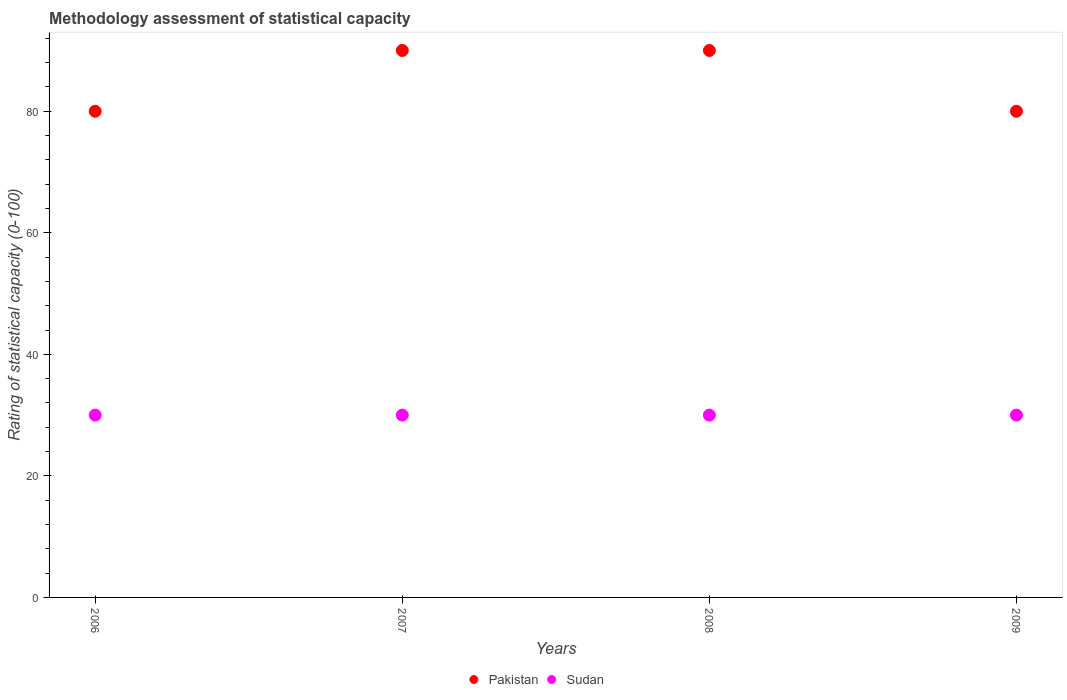How many different coloured dotlines are there?
Your answer should be compact. 2. Is the number of dotlines equal to the number of legend labels?
Keep it short and to the point. Yes. What is the rating of statistical capacity in Pakistan in 2009?
Your response must be concise. 80. Across all years, what is the maximum rating of statistical capacity in Sudan?
Provide a short and direct response. 30. Across all years, what is the minimum rating of statistical capacity in Pakistan?
Keep it short and to the point. 80. What is the total rating of statistical capacity in Pakistan in the graph?
Provide a short and direct response. 340. What is the difference between the rating of statistical capacity in Pakistan in 2007 and that in 2009?
Make the answer very short. 10. What is the difference between the rating of statistical capacity in Sudan in 2008 and the rating of statistical capacity in Pakistan in 2009?
Offer a very short reply. -50. In the year 2008, what is the difference between the rating of statistical capacity in Pakistan and rating of statistical capacity in Sudan?
Give a very brief answer. 60. In how many years, is the rating of statistical capacity in Sudan greater than 88?
Your answer should be very brief. 0. Is the rating of statistical capacity in Pakistan in 2006 less than that in 2008?
Provide a short and direct response. Yes. Is the difference between the rating of statistical capacity in Pakistan in 2008 and 2009 greater than the difference between the rating of statistical capacity in Sudan in 2008 and 2009?
Offer a very short reply. Yes. What is the difference between the highest and the lowest rating of statistical capacity in Sudan?
Ensure brevity in your answer.  0. In how many years, is the rating of statistical capacity in Sudan greater than the average rating of statistical capacity in Sudan taken over all years?
Your answer should be very brief. 0. How many dotlines are there?
Your answer should be very brief. 2. What is the difference between two consecutive major ticks on the Y-axis?
Your answer should be compact. 20. Where does the legend appear in the graph?
Your answer should be compact. Bottom center. How many legend labels are there?
Provide a succinct answer. 2. What is the title of the graph?
Offer a terse response. Methodology assessment of statistical capacity. Does "Haiti" appear as one of the legend labels in the graph?
Give a very brief answer. No. What is the label or title of the X-axis?
Ensure brevity in your answer.  Years. What is the label or title of the Y-axis?
Your response must be concise. Rating of statistical capacity (0-100). What is the Rating of statistical capacity (0-100) of Sudan in 2007?
Give a very brief answer. 30. What is the Rating of statistical capacity (0-100) in Pakistan in 2008?
Offer a terse response. 90. Across all years, what is the maximum Rating of statistical capacity (0-100) of Pakistan?
Your answer should be very brief. 90. Across all years, what is the maximum Rating of statistical capacity (0-100) in Sudan?
Give a very brief answer. 30. Across all years, what is the minimum Rating of statistical capacity (0-100) in Pakistan?
Make the answer very short. 80. Across all years, what is the minimum Rating of statistical capacity (0-100) of Sudan?
Offer a very short reply. 30. What is the total Rating of statistical capacity (0-100) of Pakistan in the graph?
Ensure brevity in your answer.  340. What is the total Rating of statistical capacity (0-100) in Sudan in the graph?
Keep it short and to the point. 120. What is the difference between the Rating of statistical capacity (0-100) in Sudan in 2006 and that in 2008?
Ensure brevity in your answer.  0. What is the difference between the Rating of statistical capacity (0-100) in Sudan in 2007 and that in 2008?
Ensure brevity in your answer.  0. What is the difference between the Rating of statistical capacity (0-100) of Pakistan in 2008 and that in 2009?
Ensure brevity in your answer.  10. What is the difference between the Rating of statistical capacity (0-100) of Pakistan in 2006 and the Rating of statistical capacity (0-100) of Sudan in 2008?
Your response must be concise. 50. What is the difference between the Rating of statistical capacity (0-100) of Pakistan in 2006 and the Rating of statistical capacity (0-100) of Sudan in 2009?
Your answer should be very brief. 50. What is the difference between the Rating of statistical capacity (0-100) of Pakistan in 2008 and the Rating of statistical capacity (0-100) of Sudan in 2009?
Make the answer very short. 60. What is the average Rating of statistical capacity (0-100) of Pakistan per year?
Your response must be concise. 85. What is the average Rating of statistical capacity (0-100) in Sudan per year?
Your response must be concise. 30. In the year 2006, what is the difference between the Rating of statistical capacity (0-100) of Pakistan and Rating of statistical capacity (0-100) of Sudan?
Give a very brief answer. 50. In the year 2007, what is the difference between the Rating of statistical capacity (0-100) of Pakistan and Rating of statistical capacity (0-100) of Sudan?
Provide a short and direct response. 60. In the year 2008, what is the difference between the Rating of statistical capacity (0-100) in Pakistan and Rating of statistical capacity (0-100) in Sudan?
Offer a very short reply. 60. In the year 2009, what is the difference between the Rating of statistical capacity (0-100) of Pakistan and Rating of statistical capacity (0-100) of Sudan?
Give a very brief answer. 50. What is the ratio of the Rating of statistical capacity (0-100) in Sudan in 2006 to that in 2007?
Offer a terse response. 1. What is the ratio of the Rating of statistical capacity (0-100) of Pakistan in 2006 to that in 2008?
Your response must be concise. 0.89. What is the ratio of the Rating of statistical capacity (0-100) of Sudan in 2007 to that in 2008?
Keep it short and to the point. 1. What is the ratio of the Rating of statistical capacity (0-100) of Pakistan in 2007 to that in 2009?
Your answer should be compact. 1.12. What is the difference between the highest and the second highest Rating of statistical capacity (0-100) in Pakistan?
Make the answer very short. 0. What is the difference between the highest and the second highest Rating of statistical capacity (0-100) in Sudan?
Your answer should be compact. 0. What is the difference between the highest and the lowest Rating of statistical capacity (0-100) in Pakistan?
Ensure brevity in your answer.  10. 